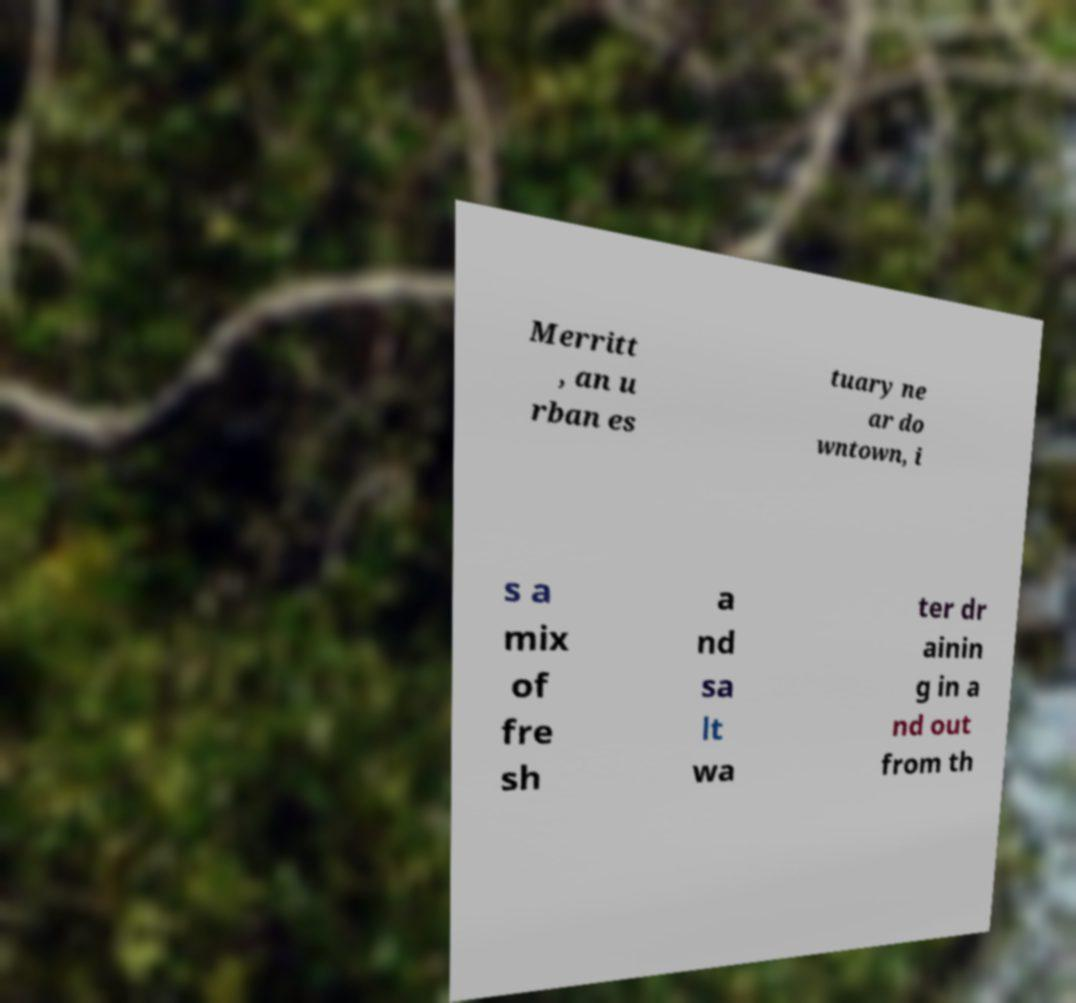Please identify and transcribe the text found in this image. Merritt , an u rban es tuary ne ar do wntown, i s a mix of fre sh a nd sa lt wa ter dr ainin g in a nd out from th 